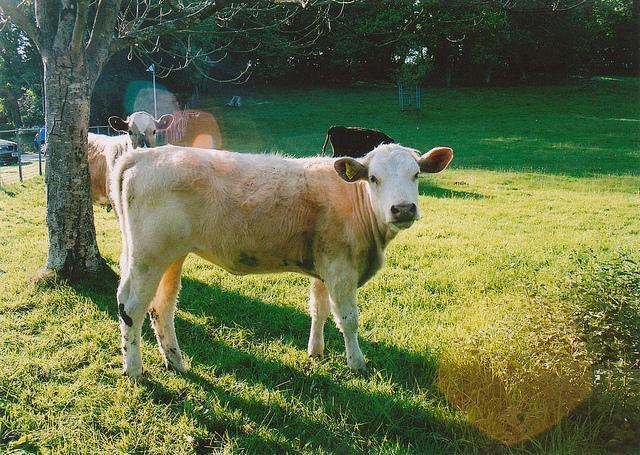How many young cows are there?
Give a very brief answer. 3. How many cows can you see?
Give a very brief answer. 2. 